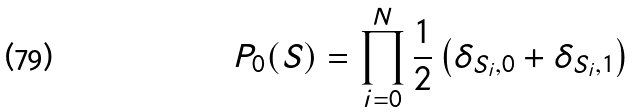<formula> <loc_0><loc_0><loc_500><loc_500>P _ { 0 } ( S ) = \prod _ { i = 0 } ^ { N } \frac { 1 } { 2 } \left ( \delta _ { S _ { i } , 0 } + \delta _ { S _ { i } , 1 } \right )</formula> 